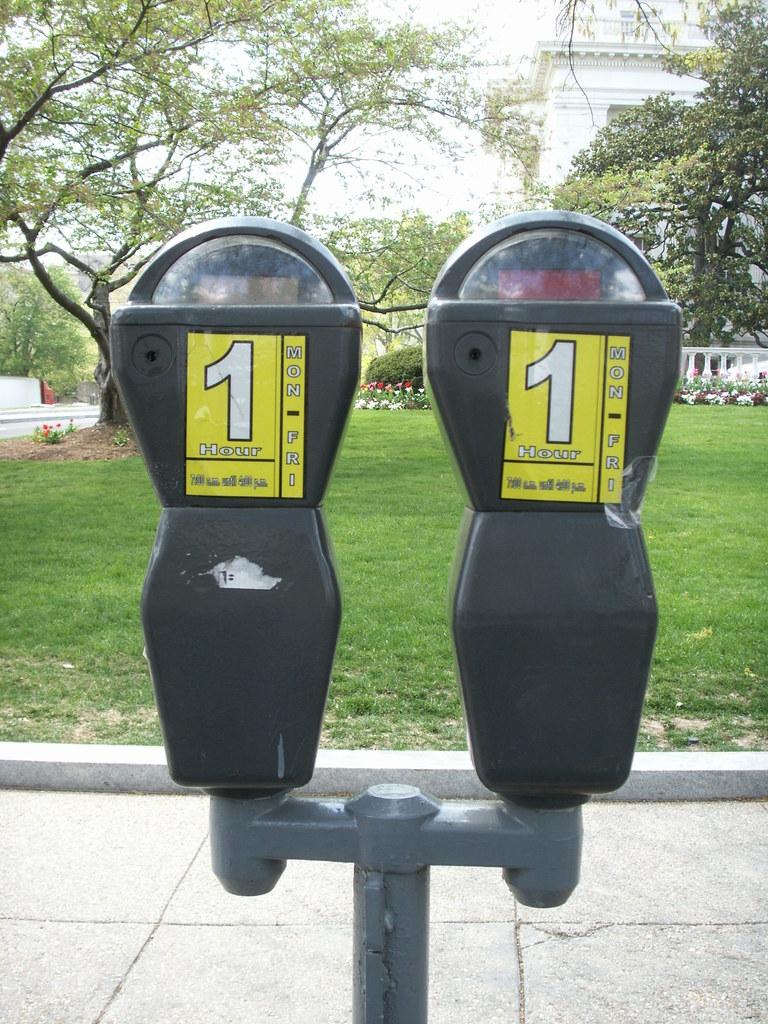What number is displayed in large font on both of these meters?
Offer a terse response. 1. What is written below number 1?
Your answer should be very brief. Hour. 